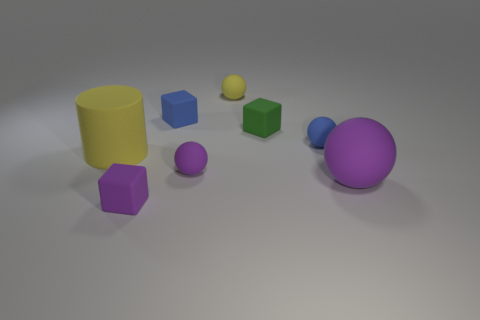Add 1 green cubes. How many objects exist? 9 Subtract all small purple balls. How many balls are left? 3 Subtract 1 blocks. How many blocks are left? 2 Subtract all purple blocks. How many blocks are left? 2 Add 3 small green rubber cubes. How many small green rubber cubes exist? 4 Subtract 0 purple cylinders. How many objects are left? 8 Subtract all blocks. How many objects are left? 5 Subtract all green spheres. Subtract all purple cylinders. How many spheres are left? 4 Subtract all yellow cylinders. How many blue spheres are left? 1 Subtract all big cylinders. Subtract all big green blocks. How many objects are left? 7 